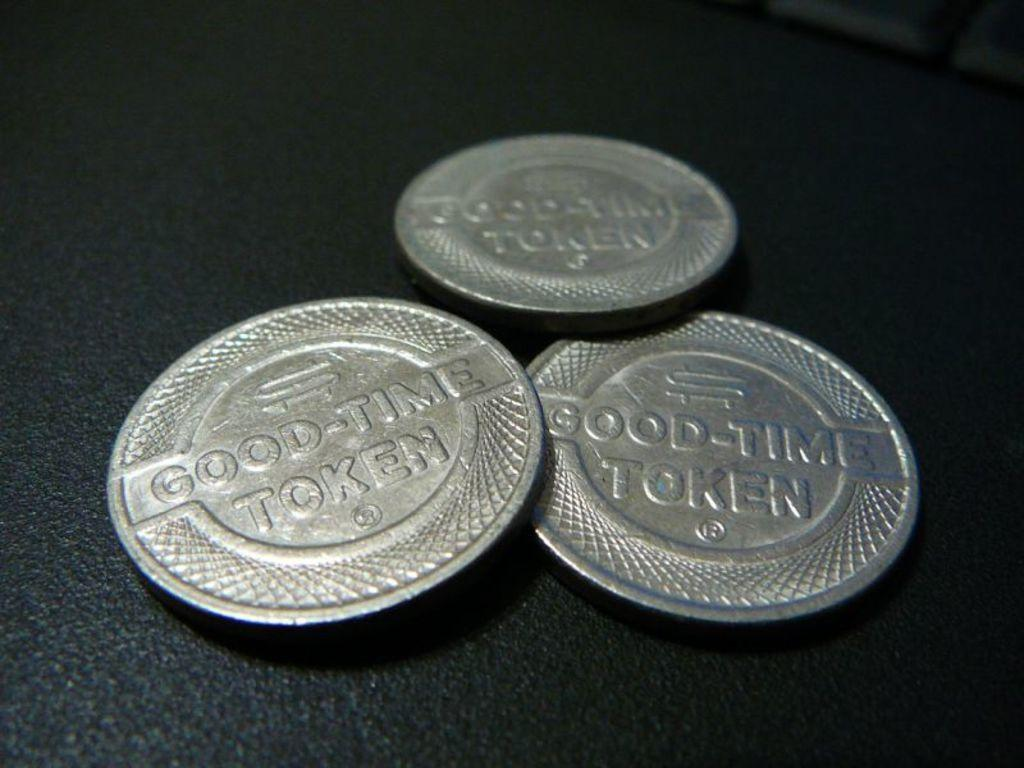Provide a one-sentence caption for the provided image. Three silver Good-Time tokens are sitting on a table. 